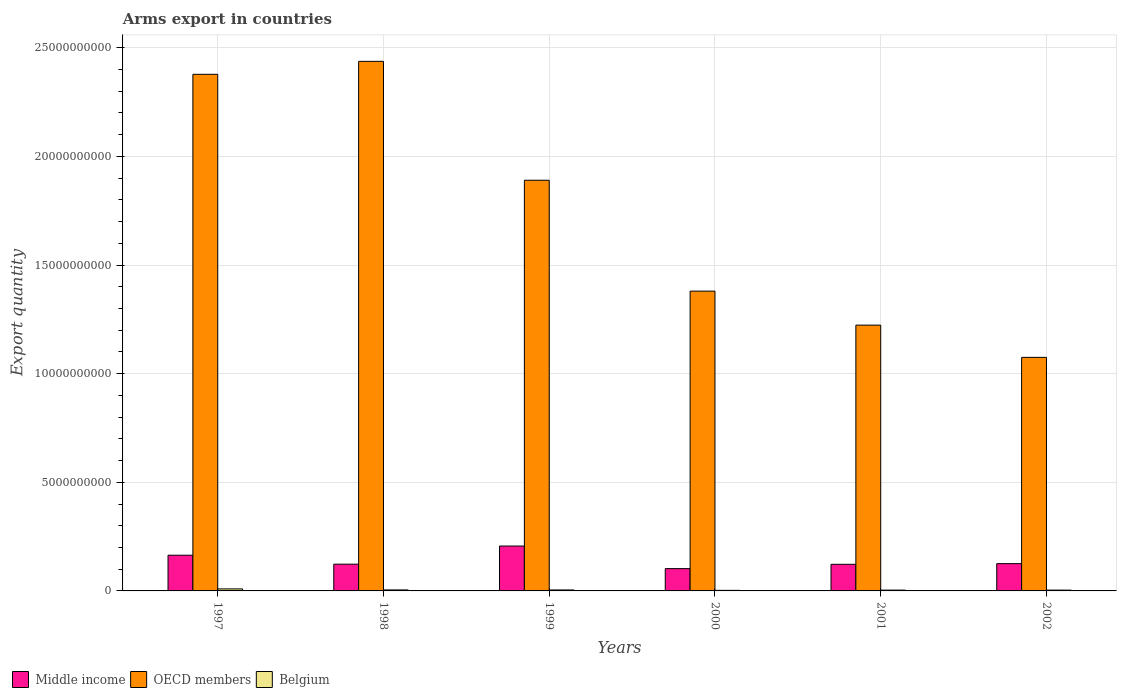Are the number of bars on each tick of the X-axis equal?
Provide a succinct answer. Yes. How many bars are there on the 2nd tick from the left?
Your answer should be very brief. 3. How many bars are there on the 1st tick from the right?
Make the answer very short. 3. What is the label of the 1st group of bars from the left?
Offer a terse response. 1997. What is the total arms export in Belgium in 2002?
Your answer should be compact. 3.70e+07. Across all years, what is the maximum total arms export in Middle income?
Give a very brief answer. 2.07e+09. Across all years, what is the minimum total arms export in Belgium?
Provide a succinct answer. 2.60e+07. In which year was the total arms export in OECD members maximum?
Provide a short and direct response. 1998. In which year was the total arms export in Middle income minimum?
Make the answer very short. 2000. What is the total total arms export in Belgium in the graph?
Offer a terse response. 2.84e+08. What is the difference between the total arms export in OECD members in 1998 and that in 2001?
Keep it short and to the point. 1.21e+1. What is the difference between the total arms export in OECD members in 2000 and the total arms export in Belgium in 2002?
Ensure brevity in your answer.  1.38e+1. What is the average total arms export in Middle income per year?
Offer a very short reply. 1.41e+09. In the year 2002, what is the difference between the total arms export in Middle income and total arms export in Belgium?
Give a very brief answer. 1.22e+09. What is the ratio of the total arms export in Belgium in 1999 to that in 2001?
Your answer should be very brief. 1.22. Is the total arms export in OECD members in 1998 less than that in 2002?
Keep it short and to the point. No. What is the difference between the highest and the second highest total arms export in OECD members?
Offer a terse response. 5.97e+08. What is the difference between the highest and the lowest total arms export in Middle income?
Offer a terse response. 1.04e+09. Is it the case that in every year, the sum of the total arms export in OECD members and total arms export in Belgium is greater than the total arms export in Middle income?
Ensure brevity in your answer.  Yes. Are all the bars in the graph horizontal?
Offer a very short reply. No. How many years are there in the graph?
Your answer should be very brief. 6. What is the difference between two consecutive major ticks on the Y-axis?
Ensure brevity in your answer.  5.00e+09. Are the values on the major ticks of Y-axis written in scientific E-notation?
Provide a succinct answer. No. Does the graph contain any zero values?
Offer a terse response. No. Where does the legend appear in the graph?
Your response must be concise. Bottom left. How are the legend labels stacked?
Ensure brevity in your answer.  Horizontal. What is the title of the graph?
Provide a short and direct response. Arms export in countries. Does "Benin" appear as one of the legend labels in the graph?
Ensure brevity in your answer.  No. What is the label or title of the X-axis?
Your response must be concise. Years. What is the label or title of the Y-axis?
Offer a terse response. Export quantity. What is the Export quantity of Middle income in 1997?
Keep it short and to the point. 1.64e+09. What is the Export quantity in OECD members in 1997?
Provide a short and direct response. 2.38e+1. What is the Export quantity of Belgium in 1997?
Your answer should be compact. 9.30e+07. What is the Export quantity of Middle income in 1998?
Make the answer very short. 1.23e+09. What is the Export quantity in OECD members in 1998?
Keep it short and to the point. 2.44e+1. What is the Export quantity of Belgium in 1998?
Ensure brevity in your answer.  4.60e+07. What is the Export quantity of Middle income in 1999?
Give a very brief answer. 2.07e+09. What is the Export quantity in OECD members in 1999?
Offer a very short reply. 1.89e+1. What is the Export quantity of Belgium in 1999?
Offer a terse response. 4.50e+07. What is the Export quantity of Middle income in 2000?
Ensure brevity in your answer.  1.03e+09. What is the Export quantity of OECD members in 2000?
Your answer should be very brief. 1.38e+1. What is the Export quantity of Belgium in 2000?
Offer a terse response. 2.60e+07. What is the Export quantity of Middle income in 2001?
Your answer should be very brief. 1.22e+09. What is the Export quantity in OECD members in 2001?
Offer a terse response. 1.22e+1. What is the Export quantity in Belgium in 2001?
Your response must be concise. 3.70e+07. What is the Export quantity of Middle income in 2002?
Give a very brief answer. 1.26e+09. What is the Export quantity in OECD members in 2002?
Give a very brief answer. 1.08e+1. What is the Export quantity in Belgium in 2002?
Provide a succinct answer. 3.70e+07. Across all years, what is the maximum Export quantity in Middle income?
Provide a succinct answer. 2.07e+09. Across all years, what is the maximum Export quantity in OECD members?
Offer a terse response. 2.44e+1. Across all years, what is the maximum Export quantity of Belgium?
Offer a very short reply. 9.30e+07. Across all years, what is the minimum Export quantity of Middle income?
Make the answer very short. 1.03e+09. Across all years, what is the minimum Export quantity in OECD members?
Your answer should be very brief. 1.08e+1. Across all years, what is the minimum Export quantity in Belgium?
Make the answer very short. 2.60e+07. What is the total Export quantity of Middle income in the graph?
Your answer should be compact. 8.45e+09. What is the total Export quantity in OECD members in the graph?
Your response must be concise. 1.04e+11. What is the total Export quantity of Belgium in the graph?
Offer a very short reply. 2.84e+08. What is the difference between the Export quantity in Middle income in 1997 and that in 1998?
Provide a short and direct response. 4.12e+08. What is the difference between the Export quantity of OECD members in 1997 and that in 1998?
Provide a short and direct response. -5.97e+08. What is the difference between the Export quantity in Belgium in 1997 and that in 1998?
Keep it short and to the point. 4.70e+07. What is the difference between the Export quantity of Middle income in 1997 and that in 1999?
Provide a succinct answer. -4.22e+08. What is the difference between the Export quantity in OECD members in 1997 and that in 1999?
Provide a succinct answer. 4.88e+09. What is the difference between the Export quantity in Belgium in 1997 and that in 1999?
Offer a terse response. 4.80e+07. What is the difference between the Export quantity in Middle income in 1997 and that in 2000?
Provide a short and direct response. 6.17e+08. What is the difference between the Export quantity in OECD members in 1997 and that in 2000?
Ensure brevity in your answer.  9.98e+09. What is the difference between the Export quantity of Belgium in 1997 and that in 2000?
Provide a succinct answer. 6.70e+07. What is the difference between the Export quantity in Middle income in 1997 and that in 2001?
Ensure brevity in your answer.  4.19e+08. What is the difference between the Export quantity of OECD members in 1997 and that in 2001?
Keep it short and to the point. 1.15e+1. What is the difference between the Export quantity of Belgium in 1997 and that in 2001?
Your answer should be very brief. 5.60e+07. What is the difference between the Export quantity in Middle income in 1997 and that in 2002?
Provide a succinct answer. 3.88e+08. What is the difference between the Export quantity of OECD members in 1997 and that in 2002?
Offer a terse response. 1.30e+1. What is the difference between the Export quantity of Belgium in 1997 and that in 2002?
Offer a terse response. 5.60e+07. What is the difference between the Export quantity in Middle income in 1998 and that in 1999?
Provide a succinct answer. -8.34e+08. What is the difference between the Export quantity in OECD members in 1998 and that in 1999?
Your response must be concise. 5.47e+09. What is the difference between the Export quantity in Belgium in 1998 and that in 1999?
Your response must be concise. 1.00e+06. What is the difference between the Export quantity of Middle income in 1998 and that in 2000?
Offer a very short reply. 2.05e+08. What is the difference between the Export quantity of OECD members in 1998 and that in 2000?
Keep it short and to the point. 1.06e+1. What is the difference between the Export quantity in Middle income in 1998 and that in 2001?
Your answer should be very brief. 7.00e+06. What is the difference between the Export quantity in OECD members in 1998 and that in 2001?
Ensure brevity in your answer.  1.21e+1. What is the difference between the Export quantity in Belgium in 1998 and that in 2001?
Make the answer very short. 9.00e+06. What is the difference between the Export quantity in Middle income in 1998 and that in 2002?
Your answer should be very brief. -2.40e+07. What is the difference between the Export quantity in OECD members in 1998 and that in 2002?
Give a very brief answer. 1.36e+1. What is the difference between the Export quantity of Belgium in 1998 and that in 2002?
Provide a succinct answer. 9.00e+06. What is the difference between the Export quantity in Middle income in 1999 and that in 2000?
Make the answer very short. 1.04e+09. What is the difference between the Export quantity in OECD members in 1999 and that in 2000?
Offer a very short reply. 5.10e+09. What is the difference between the Export quantity in Belgium in 1999 and that in 2000?
Offer a terse response. 1.90e+07. What is the difference between the Export quantity of Middle income in 1999 and that in 2001?
Provide a short and direct response. 8.41e+08. What is the difference between the Export quantity of OECD members in 1999 and that in 2001?
Make the answer very short. 6.67e+09. What is the difference between the Export quantity in Belgium in 1999 and that in 2001?
Ensure brevity in your answer.  8.00e+06. What is the difference between the Export quantity in Middle income in 1999 and that in 2002?
Offer a terse response. 8.10e+08. What is the difference between the Export quantity of OECD members in 1999 and that in 2002?
Provide a short and direct response. 8.15e+09. What is the difference between the Export quantity of Middle income in 2000 and that in 2001?
Offer a terse response. -1.98e+08. What is the difference between the Export quantity in OECD members in 2000 and that in 2001?
Your answer should be very brief. 1.56e+09. What is the difference between the Export quantity in Belgium in 2000 and that in 2001?
Your answer should be very brief. -1.10e+07. What is the difference between the Export quantity in Middle income in 2000 and that in 2002?
Give a very brief answer. -2.29e+08. What is the difference between the Export quantity in OECD members in 2000 and that in 2002?
Provide a short and direct response. 3.05e+09. What is the difference between the Export quantity in Belgium in 2000 and that in 2002?
Your answer should be very brief. -1.10e+07. What is the difference between the Export quantity of Middle income in 2001 and that in 2002?
Make the answer very short. -3.10e+07. What is the difference between the Export quantity in OECD members in 2001 and that in 2002?
Ensure brevity in your answer.  1.48e+09. What is the difference between the Export quantity of Middle income in 1997 and the Export quantity of OECD members in 1998?
Your answer should be very brief. -2.27e+1. What is the difference between the Export quantity of Middle income in 1997 and the Export quantity of Belgium in 1998?
Provide a short and direct response. 1.60e+09. What is the difference between the Export quantity in OECD members in 1997 and the Export quantity in Belgium in 1998?
Provide a succinct answer. 2.37e+1. What is the difference between the Export quantity in Middle income in 1997 and the Export quantity in OECD members in 1999?
Provide a short and direct response. -1.73e+1. What is the difference between the Export quantity of Middle income in 1997 and the Export quantity of Belgium in 1999?
Offer a terse response. 1.60e+09. What is the difference between the Export quantity in OECD members in 1997 and the Export quantity in Belgium in 1999?
Keep it short and to the point. 2.37e+1. What is the difference between the Export quantity of Middle income in 1997 and the Export quantity of OECD members in 2000?
Your answer should be very brief. -1.22e+1. What is the difference between the Export quantity of Middle income in 1997 and the Export quantity of Belgium in 2000?
Give a very brief answer. 1.62e+09. What is the difference between the Export quantity in OECD members in 1997 and the Export quantity in Belgium in 2000?
Provide a short and direct response. 2.38e+1. What is the difference between the Export quantity in Middle income in 1997 and the Export quantity in OECD members in 2001?
Provide a short and direct response. -1.06e+1. What is the difference between the Export quantity in Middle income in 1997 and the Export quantity in Belgium in 2001?
Offer a very short reply. 1.61e+09. What is the difference between the Export quantity of OECD members in 1997 and the Export quantity of Belgium in 2001?
Your answer should be very brief. 2.37e+1. What is the difference between the Export quantity of Middle income in 1997 and the Export quantity of OECD members in 2002?
Ensure brevity in your answer.  -9.11e+09. What is the difference between the Export quantity in Middle income in 1997 and the Export quantity in Belgium in 2002?
Keep it short and to the point. 1.61e+09. What is the difference between the Export quantity of OECD members in 1997 and the Export quantity of Belgium in 2002?
Make the answer very short. 2.37e+1. What is the difference between the Export quantity of Middle income in 1998 and the Export quantity of OECD members in 1999?
Provide a short and direct response. -1.77e+1. What is the difference between the Export quantity of Middle income in 1998 and the Export quantity of Belgium in 1999?
Ensure brevity in your answer.  1.19e+09. What is the difference between the Export quantity of OECD members in 1998 and the Export quantity of Belgium in 1999?
Offer a terse response. 2.43e+1. What is the difference between the Export quantity of Middle income in 1998 and the Export quantity of OECD members in 2000?
Your answer should be compact. -1.26e+1. What is the difference between the Export quantity of Middle income in 1998 and the Export quantity of Belgium in 2000?
Your response must be concise. 1.21e+09. What is the difference between the Export quantity of OECD members in 1998 and the Export quantity of Belgium in 2000?
Provide a succinct answer. 2.44e+1. What is the difference between the Export quantity in Middle income in 1998 and the Export quantity in OECD members in 2001?
Offer a very short reply. -1.10e+1. What is the difference between the Export quantity in Middle income in 1998 and the Export quantity in Belgium in 2001?
Ensure brevity in your answer.  1.20e+09. What is the difference between the Export quantity in OECD members in 1998 and the Export quantity in Belgium in 2001?
Offer a terse response. 2.43e+1. What is the difference between the Export quantity of Middle income in 1998 and the Export quantity of OECD members in 2002?
Keep it short and to the point. -9.52e+09. What is the difference between the Export quantity in Middle income in 1998 and the Export quantity in Belgium in 2002?
Keep it short and to the point. 1.20e+09. What is the difference between the Export quantity of OECD members in 1998 and the Export quantity of Belgium in 2002?
Ensure brevity in your answer.  2.43e+1. What is the difference between the Export quantity in Middle income in 1999 and the Export quantity in OECD members in 2000?
Provide a short and direct response. -1.17e+1. What is the difference between the Export quantity in Middle income in 1999 and the Export quantity in Belgium in 2000?
Give a very brief answer. 2.04e+09. What is the difference between the Export quantity in OECD members in 1999 and the Export quantity in Belgium in 2000?
Your answer should be very brief. 1.89e+1. What is the difference between the Export quantity in Middle income in 1999 and the Export quantity in OECD members in 2001?
Your answer should be compact. -1.02e+1. What is the difference between the Export quantity of Middle income in 1999 and the Export quantity of Belgium in 2001?
Your answer should be compact. 2.03e+09. What is the difference between the Export quantity in OECD members in 1999 and the Export quantity in Belgium in 2001?
Your response must be concise. 1.89e+1. What is the difference between the Export quantity in Middle income in 1999 and the Export quantity in OECD members in 2002?
Provide a short and direct response. -8.68e+09. What is the difference between the Export quantity of Middle income in 1999 and the Export quantity of Belgium in 2002?
Your response must be concise. 2.03e+09. What is the difference between the Export quantity of OECD members in 1999 and the Export quantity of Belgium in 2002?
Your answer should be very brief. 1.89e+1. What is the difference between the Export quantity of Middle income in 2000 and the Export quantity of OECD members in 2001?
Ensure brevity in your answer.  -1.12e+1. What is the difference between the Export quantity in Middle income in 2000 and the Export quantity in Belgium in 2001?
Your response must be concise. 9.90e+08. What is the difference between the Export quantity of OECD members in 2000 and the Export quantity of Belgium in 2001?
Make the answer very short. 1.38e+1. What is the difference between the Export quantity in Middle income in 2000 and the Export quantity in OECD members in 2002?
Keep it short and to the point. -9.72e+09. What is the difference between the Export quantity of Middle income in 2000 and the Export quantity of Belgium in 2002?
Offer a terse response. 9.90e+08. What is the difference between the Export quantity of OECD members in 2000 and the Export quantity of Belgium in 2002?
Ensure brevity in your answer.  1.38e+1. What is the difference between the Export quantity in Middle income in 2001 and the Export quantity in OECD members in 2002?
Your response must be concise. -9.53e+09. What is the difference between the Export quantity in Middle income in 2001 and the Export quantity in Belgium in 2002?
Offer a very short reply. 1.19e+09. What is the difference between the Export quantity in OECD members in 2001 and the Export quantity in Belgium in 2002?
Your answer should be very brief. 1.22e+1. What is the average Export quantity in Middle income per year?
Your answer should be compact. 1.41e+09. What is the average Export quantity in OECD members per year?
Provide a short and direct response. 1.73e+1. What is the average Export quantity in Belgium per year?
Keep it short and to the point. 4.73e+07. In the year 1997, what is the difference between the Export quantity in Middle income and Export quantity in OECD members?
Your response must be concise. -2.21e+1. In the year 1997, what is the difference between the Export quantity in Middle income and Export quantity in Belgium?
Provide a succinct answer. 1.55e+09. In the year 1997, what is the difference between the Export quantity of OECD members and Export quantity of Belgium?
Provide a succinct answer. 2.37e+1. In the year 1998, what is the difference between the Export quantity in Middle income and Export quantity in OECD members?
Make the answer very short. -2.31e+1. In the year 1998, what is the difference between the Export quantity of Middle income and Export quantity of Belgium?
Give a very brief answer. 1.19e+09. In the year 1998, what is the difference between the Export quantity in OECD members and Export quantity in Belgium?
Ensure brevity in your answer.  2.43e+1. In the year 1999, what is the difference between the Export quantity of Middle income and Export quantity of OECD members?
Keep it short and to the point. -1.68e+1. In the year 1999, what is the difference between the Export quantity of Middle income and Export quantity of Belgium?
Provide a succinct answer. 2.02e+09. In the year 1999, what is the difference between the Export quantity in OECD members and Export quantity in Belgium?
Give a very brief answer. 1.89e+1. In the year 2000, what is the difference between the Export quantity of Middle income and Export quantity of OECD members?
Provide a succinct answer. -1.28e+1. In the year 2000, what is the difference between the Export quantity in Middle income and Export quantity in Belgium?
Make the answer very short. 1.00e+09. In the year 2000, what is the difference between the Export quantity of OECD members and Export quantity of Belgium?
Ensure brevity in your answer.  1.38e+1. In the year 2001, what is the difference between the Export quantity of Middle income and Export quantity of OECD members?
Make the answer very short. -1.10e+1. In the year 2001, what is the difference between the Export quantity in Middle income and Export quantity in Belgium?
Your answer should be compact. 1.19e+09. In the year 2001, what is the difference between the Export quantity of OECD members and Export quantity of Belgium?
Your response must be concise. 1.22e+1. In the year 2002, what is the difference between the Export quantity of Middle income and Export quantity of OECD members?
Offer a terse response. -9.50e+09. In the year 2002, what is the difference between the Export quantity in Middle income and Export quantity in Belgium?
Provide a short and direct response. 1.22e+09. In the year 2002, what is the difference between the Export quantity in OECD members and Export quantity in Belgium?
Ensure brevity in your answer.  1.07e+1. What is the ratio of the Export quantity in Middle income in 1997 to that in 1998?
Your answer should be compact. 1.33. What is the ratio of the Export quantity in OECD members in 1997 to that in 1998?
Ensure brevity in your answer.  0.98. What is the ratio of the Export quantity of Belgium in 1997 to that in 1998?
Your response must be concise. 2.02. What is the ratio of the Export quantity of Middle income in 1997 to that in 1999?
Make the answer very short. 0.8. What is the ratio of the Export quantity in OECD members in 1997 to that in 1999?
Provide a short and direct response. 1.26. What is the ratio of the Export quantity of Belgium in 1997 to that in 1999?
Offer a terse response. 2.07. What is the ratio of the Export quantity of Middle income in 1997 to that in 2000?
Your answer should be very brief. 1.6. What is the ratio of the Export quantity in OECD members in 1997 to that in 2000?
Keep it short and to the point. 1.72. What is the ratio of the Export quantity in Belgium in 1997 to that in 2000?
Provide a succinct answer. 3.58. What is the ratio of the Export quantity of Middle income in 1997 to that in 2001?
Provide a succinct answer. 1.34. What is the ratio of the Export quantity of OECD members in 1997 to that in 2001?
Your answer should be very brief. 1.94. What is the ratio of the Export quantity of Belgium in 1997 to that in 2001?
Offer a very short reply. 2.51. What is the ratio of the Export quantity in Middle income in 1997 to that in 2002?
Your response must be concise. 1.31. What is the ratio of the Export quantity of OECD members in 1997 to that in 2002?
Provide a short and direct response. 2.21. What is the ratio of the Export quantity of Belgium in 1997 to that in 2002?
Your answer should be very brief. 2.51. What is the ratio of the Export quantity of Middle income in 1998 to that in 1999?
Your answer should be very brief. 0.6. What is the ratio of the Export quantity of OECD members in 1998 to that in 1999?
Your answer should be very brief. 1.29. What is the ratio of the Export quantity in Belgium in 1998 to that in 1999?
Provide a succinct answer. 1.02. What is the ratio of the Export quantity of Middle income in 1998 to that in 2000?
Offer a terse response. 1.2. What is the ratio of the Export quantity of OECD members in 1998 to that in 2000?
Provide a succinct answer. 1.77. What is the ratio of the Export quantity in Belgium in 1998 to that in 2000?
Keep it short and to the point. 1.77. What is the ratio of the Export quantity of OECD members in 1998 to that in 2001?
Your answer should be very brief. 1.99. What is the ratio of the Export quantity of Belgium in 1998 to that in 2001?
Keep it short and to the point. 1.24. What is the ratio of the Export quantity of Middle income in 1998 to that in 2002?
Provide a short and direct response. 0.98. What is the ratio of the Export quantity in OECD members in 1998 to that in 2002?
Your answer should be very brief. 2.27. What is the ratio of the Export quantity of Belgium in 1998 to that in 2002?
Offer a terse response. 1.24. What is the ratio of the Export quantity in Middle income in 1999 to that in 2000?
Keep it short and to the point. 2.01. What is the ratio of the Export quantity in OECD members in 1999 to that in 2000?
Ensure brevity in your answer.  1.37. What is the ratio of the Export quantity in Belgium in 1999 to that in 2000?
Make the answer very short. 1.73. What is the ratio of the Export quantity in Middle income in 1999 to that in 2001?
Offer a very short reply. 1.69. What is the ratio of the Export quantity in OECD members in 1999 to that in 2001?
Offer a terse response. 1.55. What is the ratio of the Export quantity in Belgium in 1999 to that in 2001?
Offer a very short reply. 1.22. What is the ratio of the Export quantity of Middle income in 1999 to that in 2002?
Your response must be concise. 1.64. What is the ratio of the Export quantity of OECD members in 1999 to that in 2002?
Keep it short and to the point. 1.76. What is the ratio of the Export quantity in Belgium in 1999 to that in 2002?
Keep it short and to the point. 1.22. What is the ratio of the Export quantity in Middle income in 2000 to that in 2001?
Make the answer very short. 0.84. What is the ratio of the Export quantity of OECD members in 2000 to that in 2001?
Provide a succinct answer. 1.13. What is the ratio of the Export quantity in Belgium in 2000 to that in 2001?
Keep it short and to the point. 0.7. What is the ratio of the Export quantity of Middle income in 2000 to that in 2002?
Provide a succinct answer. 0.82. What is the ratio of the Export quantity of OECD members in 2000 to that in 2002?
Your response must be concise. 1.28. What is the ratio of the Export quantity in Belgium in 2000 to that in 2002?
Your answer should be very brief. 0.7. What is the ratio of the Export quantity of Middle income in 2001 to that in 2002?
Ensure brevity in your answer.  0.98. What is the ratio of the Export quantity of OECD members in 2001 to that in 2002?
Provide a short and direct response. 1.14. What is the ratio of the Export quantity in Belgium in 2001 to that in 2002?
Your answer should be compact. 1. What is the difference between the highest and the second highest Export quantity of Middle income?
Give a very brief answer. 4.22e+08. What is the difference between the highest and the second highest Export quantity in OECD members?
Your answer should be very brief. 5.97e+08. What is the difference between the highest and the second highest Export quantity in Belgium?
Provide a short and direct response. 4.70e+07. What is the difference between the highest and the lowest Export quantity in Middle income?
Give a very brief answer. 1.04e+09. What is the difference between the highest and the lowest Export quantity in OECD members?
Keep it short and to the point. 1.36e+1. What is the difference between the highest and the lowest Export quantity of Belgium?
Keep it short and to the point. 6.70e+07. 